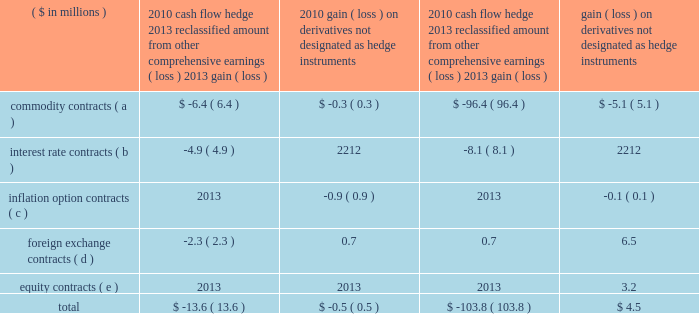Page 77 of 100 ball corporation and subsidiaries notes to consolidated financial statements 18 .
Financial instruments and risk management ( continued ) the table provides the effects of derivative instruments in the consolidated statement of earnings and on accumulated other comprehensive earnings ( loss ) for the year ended december 31: .
( a ) gains and losses on commodity contracts are recorded in sales and cost of sales in the statement of earnings .
Virtually all these expenses were passed through to our customers , resulting in no significant impact to earnings .
( b ) losses on interest contracts are recorded in interest expense in the statement of earnings .
( c ) gains and losses on inflation options are recorded in cost of sales in the statement of earnings .
( d ) gains and losses on foreign currency contracts to hedge the sales of products are recorded in cost of sales .
Gains and losses on foreign currency hedges used for translation between segments are reflected in selling , general and administrative expenses in the consolidated statement of earnings .
( e ) gains and losses on equity put option contracts are recorded in selling , general and administrative expenses in the consolidated statement of earnings. .
For 2010 , foreign exchange contracts were what portion of the reclassification to ordinary income? 
Computations: (2.3 / 13.6)
Answer: 0.16912. 